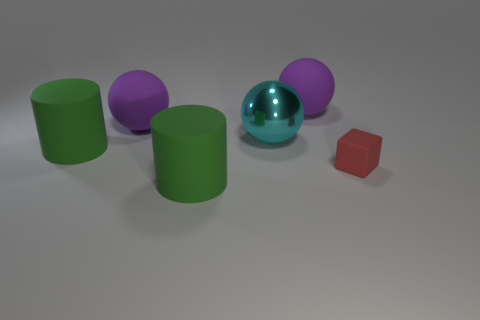Subtract all gray cylinders. How many purple spheres are left? 2 Subtract all purple rubber spheres. How many spheres are left? 1 Add 4 metallic things. How many objects exist? 10 Subtract all cylinders. How many objects are left? 4 Add 6 large shiny spheres. How many large shiny spheres exist? 7 Subtract 0 red spheres. How many objects are left? 6 Subtract all purple rubber things. Subtract all big purple rubber things. How many objects are left? 2 Add 3 large purple rubber balls. How many large purple rubber balls are left? 5 